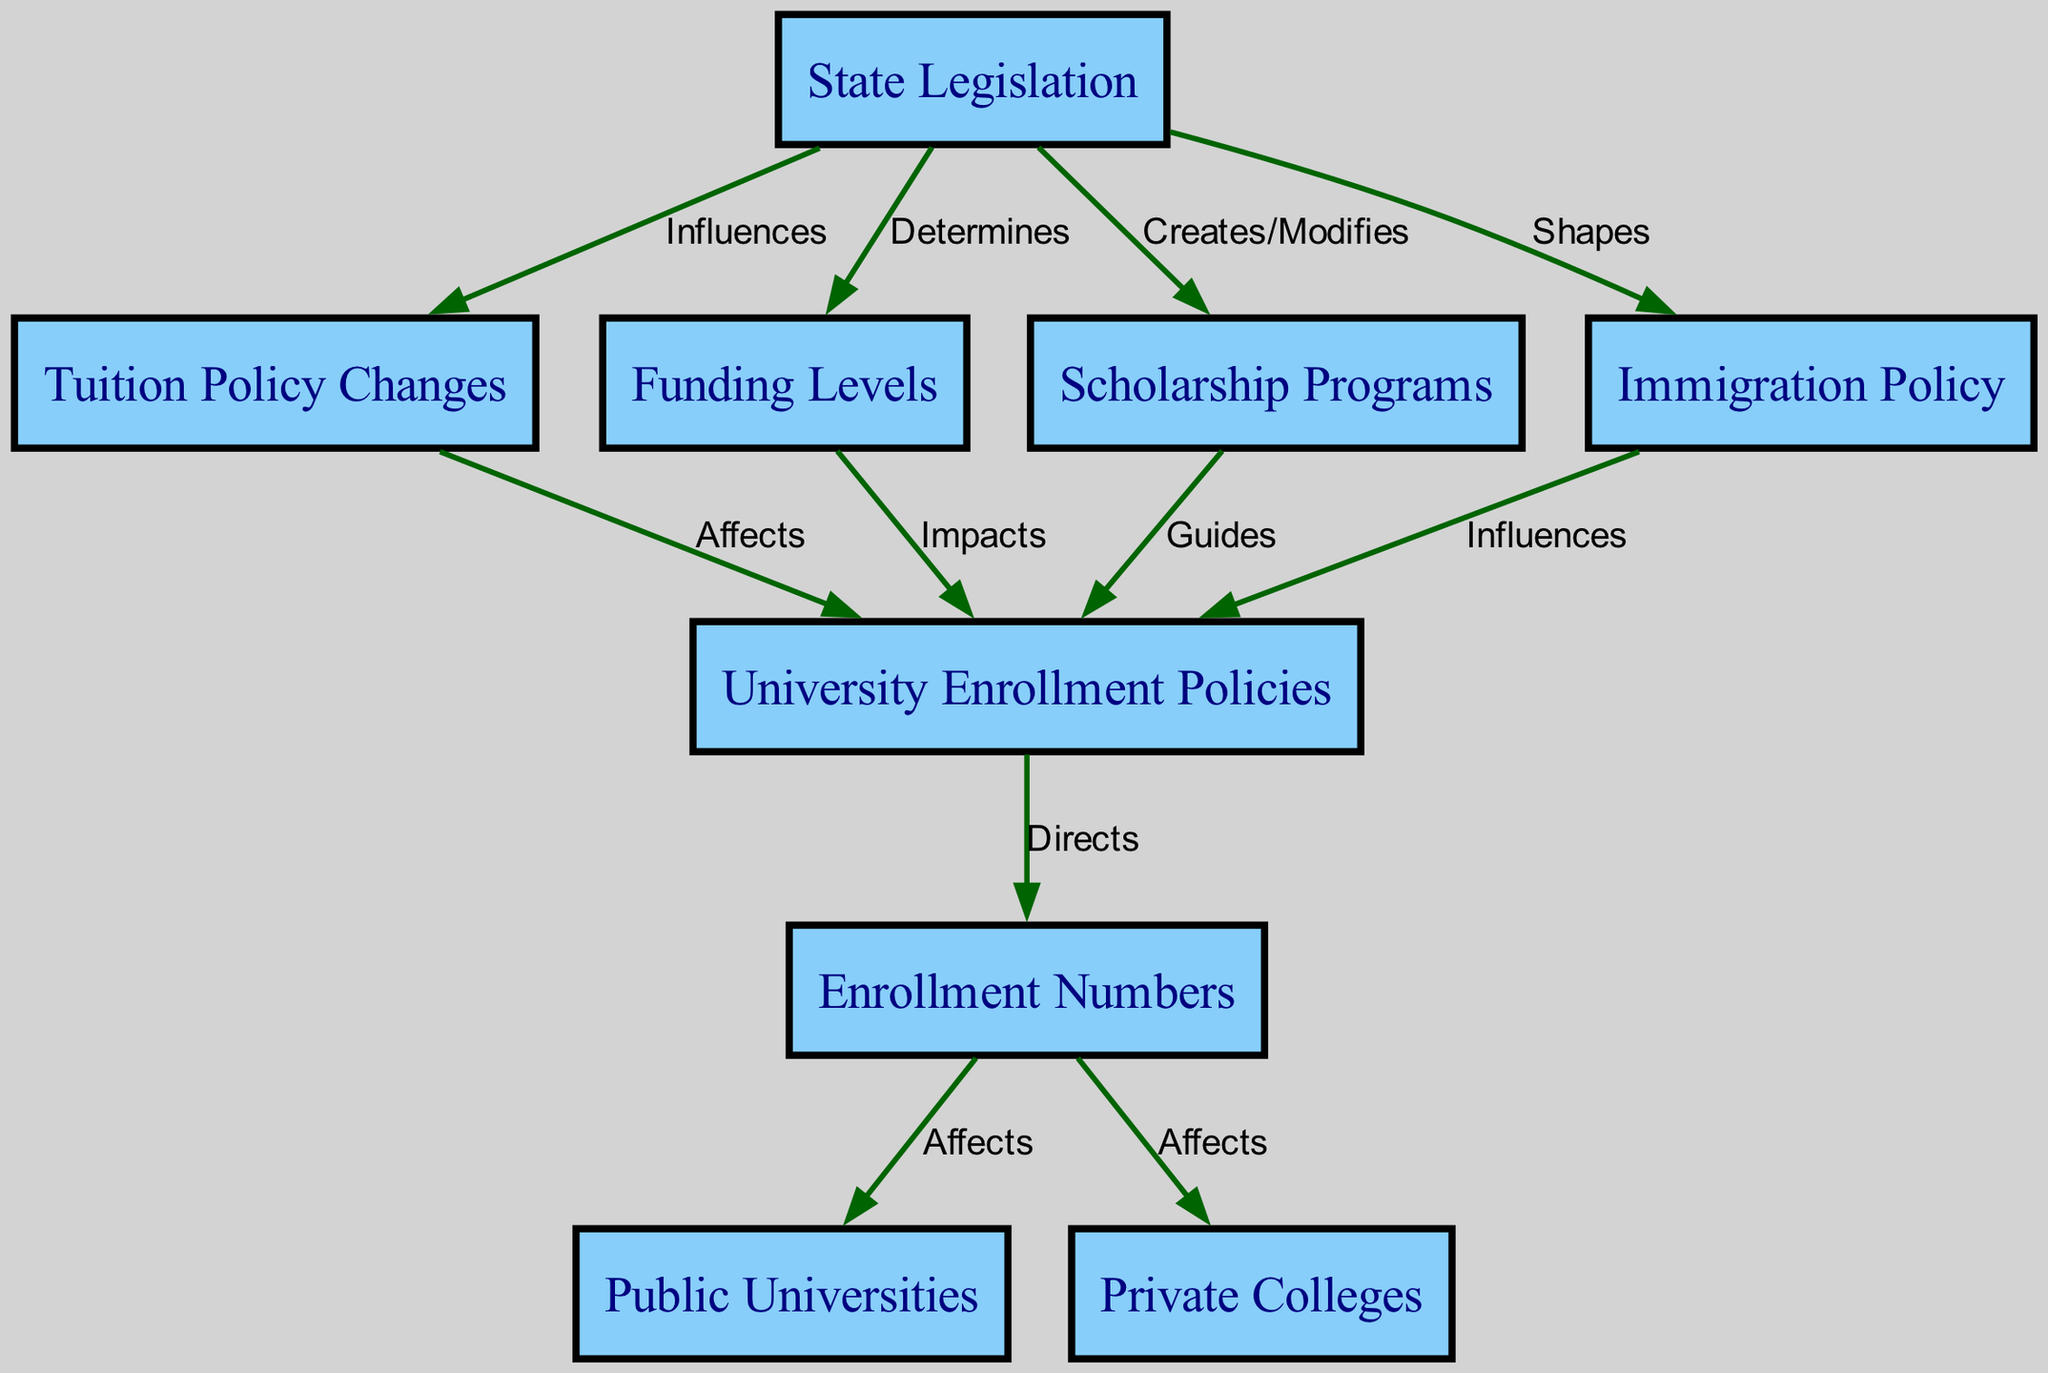What is the main topic of the diagram? The nodes in the diagram indicate a focus on how state legislation affects higher education enrollment, with connections between various elements like tuition policy and funding levels.
Answer: State Legislation How many nodes are present in the diagram? By counting the nodes listed in the data, we see there are a total of 9 nodes that represent different elements in the flow of the diagram.
Answer: 9 Which node is influenced by immigration policy? The diagram shows that "University Enrollment Policies" is influenced by "Immigration Policy," indicating a direct relationship where immigration laws affect university policies.
Answer: University Enrollment Policies What does university policies directly affect? According to the diagram, "University Enrollment Policies" have a direct relationship with "Enrollment Numbers," meaning that the policies adopted by universities influence how many students enroll.
Answer: Enrollment Numbers What type of relationship exists between funding levels and university policies? The edge between "Funding Levels" and "University Policies" indicates an "Impacts" relationship, showing that changes in funding influence the policies adopted by universities.
Answer: Impacts Which factors can affect enrollment numbers? The diagram highlights that both "Public Universities" and "Private Colleges" are affected by "Enrollment Numbers," meaning these numbers influence student distribution between these types of institutions.
Answer: Public Universities, Private Colleges What influences scholarship programs? The state legislation creates or modifies "Scholarship Programs," illustrating that changes in laws can lead to adjustments in state-sponsored financial aid opportunities for students.
Answer: Creates/Modifies How do changes in tuition policy affect university policies? There is an arrow labeled "Affects" that connects "Tuition Policy Changes" to "University Enrollment Policies," indicating that alterations in tuition fees lead to adjustments in how universities manage enrollment.
Answer: Affects What is the relationship between public universities and enrollment numbers? The diagram indicates a relationship where "Enrollment Numbers" affect "Public Universities," suggesting the quantity of enrolled students directly impacts these state-funded institutions.
Answer: Affects 